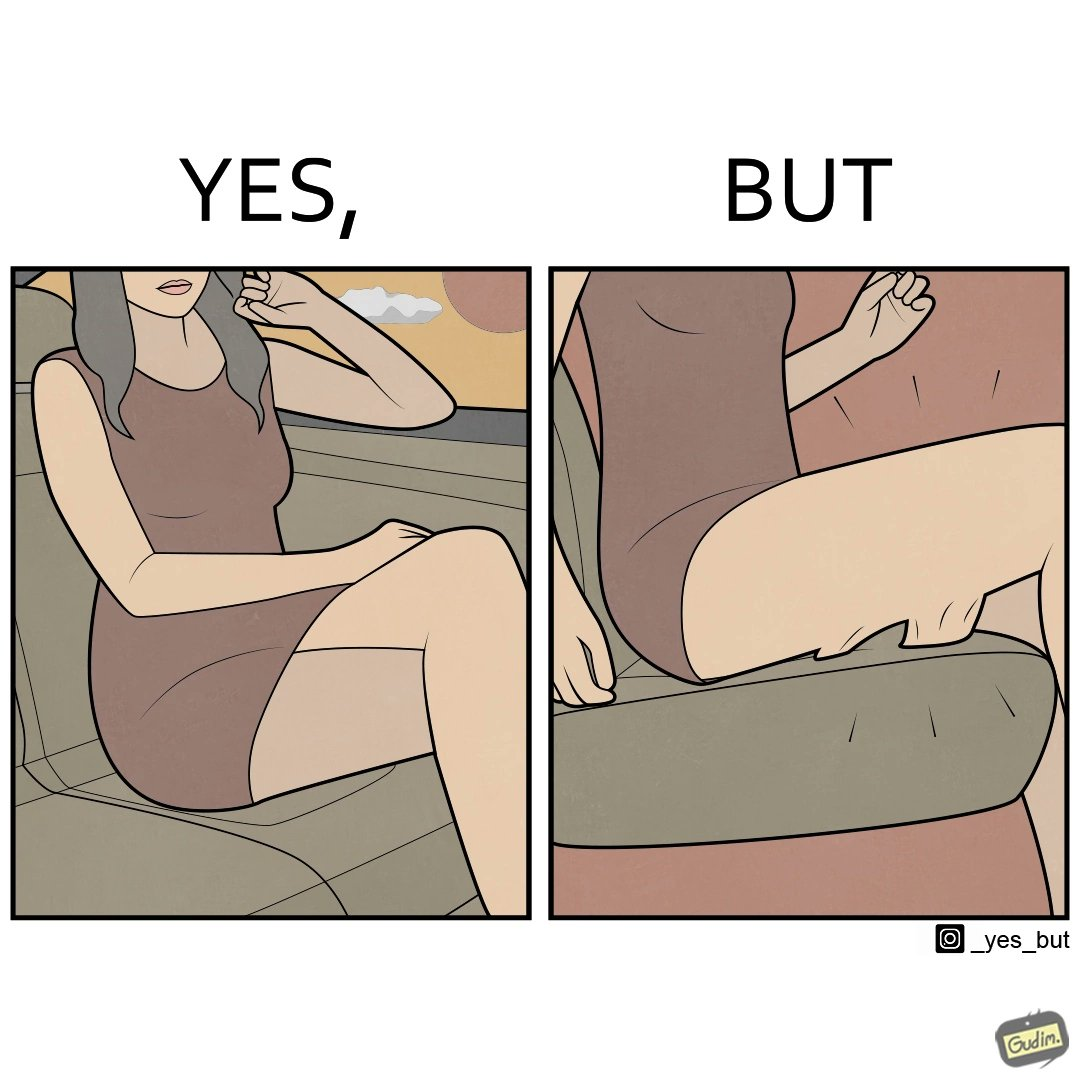Describe the content of this image. The image is ironic, because the woman is wearing a short dress to look stylish but she had to face inconvenience while travelling in car due to her short dress only. 